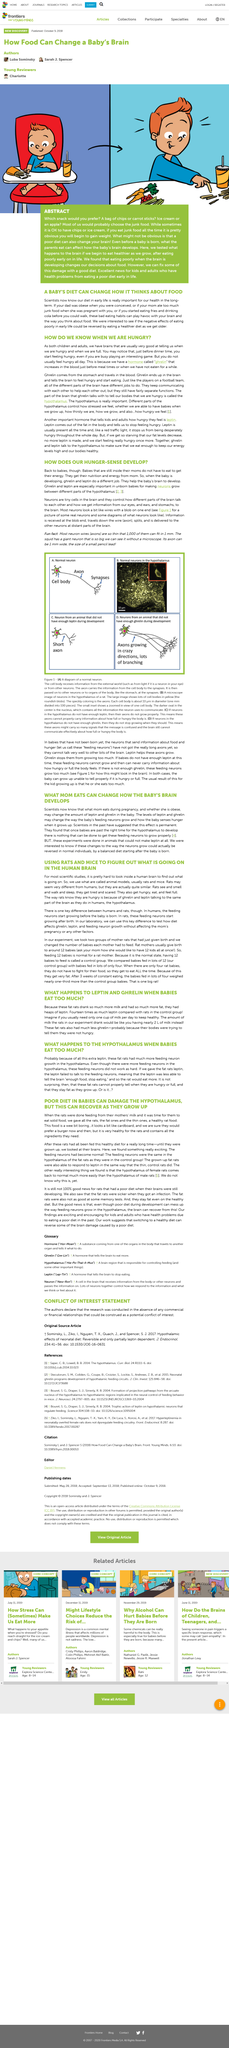Identify some key points in this picture. Ghrelin, a hormone produced by the stomach, originates in the stomach. Babies inside their mothers do not have to eat to obtain energy, as they receive it from the nutrients and nourishment provided by their mothers through the placenta. The hormones ghrelin and leptin are crucial in the growth of neurons between different regions of the hypothalamus in unborn babies. The hormone Leptin regulates the feelings of hunger by signaling the body to stop eating when it has sufficient nutrients. It is difficult to study the human brain and understand its activities in most scientific studies. 